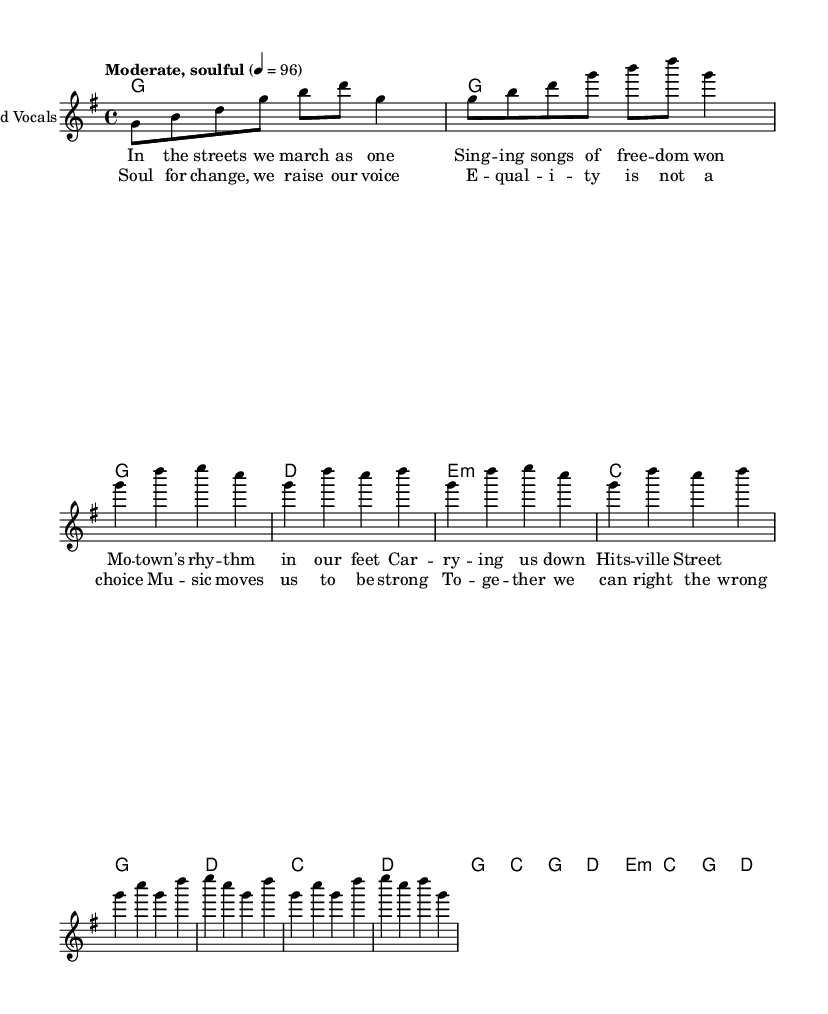What is the key signature of this music? The key signature is G major, which has one sharp (F#). This is indicated by the key signature symbol at the beginning of the staff.
Answer: G major What is the time signature of the piece? The time signature is 4/4, which is shown at the beginning of the piece next to the key signature. It indicates that there are four beats in each measure and the quarter note receives one beat.
Answer: 4/4 What is the tempo marking for this piece? The tempo marking is "Moderate, soulful," with a metronome marking of quarter note equals 96 beats per minute, and it is written at the start of the score.
Answer: Moderate, soulful How many measures are in the chorus section? The chorus section contains 4 measures, as counted in the provided musical notation for that section.
Answer: 4 What musical theme is reflected in the lyrics? The lyrics reflect the theme of civil rights and unity, emphasizing change and equality, which corresponds with Motown's cultural impact during the civil rights era.
Answer: Unity and equality Which instrument is designated for the lead vocals? The instrument designated for the lead vocals is "Lead Vocals," as indicated in the score with the label under the staff.
Answer: Lead Vocals What type of harmony is used in the verse? The harmony used in the verse consists of major and minor chords, specifically G, D, E minor, and C, which align with the mood of the lyrics addressing social themes.
Answer: Major and minor chords 